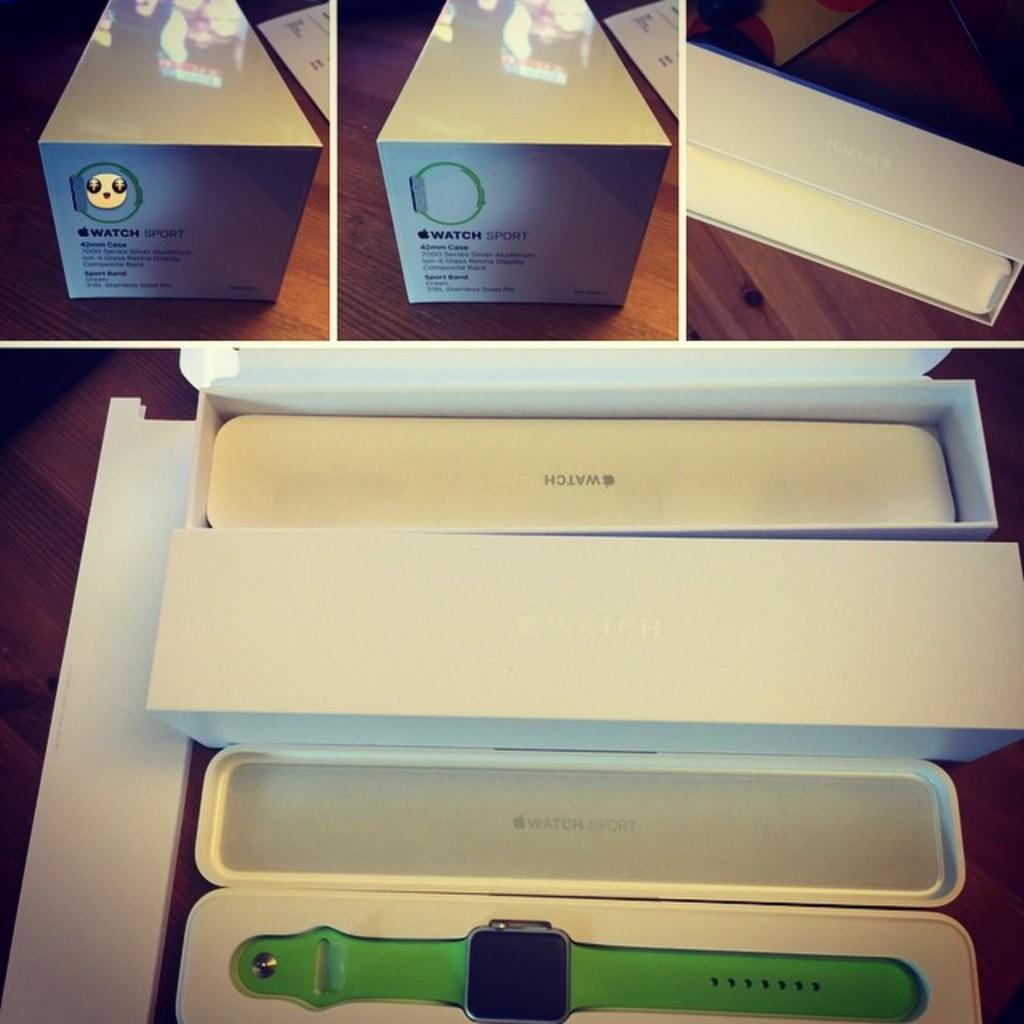<image>
Present a compact description of the photo's key features. A green watch sport watch in a white box. 